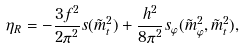<formula> <loc_0><loc_0><loc_500><loc_500>\eta _ { R } = - \frac { 3 f ^ { 2 } } { 2 \pi ^ { 2 } } s ( \tilde { m } _ { t } ^ { 2 } ) + \frac { h ^ { 2 } } { 8 \pi ^ { 2 } } s _ { \varphi } ( \tilde { m } _ { \varphi } ^ { 2 } , \tilde { m } _ { t } ^ { 2 } ) ,</formula> 